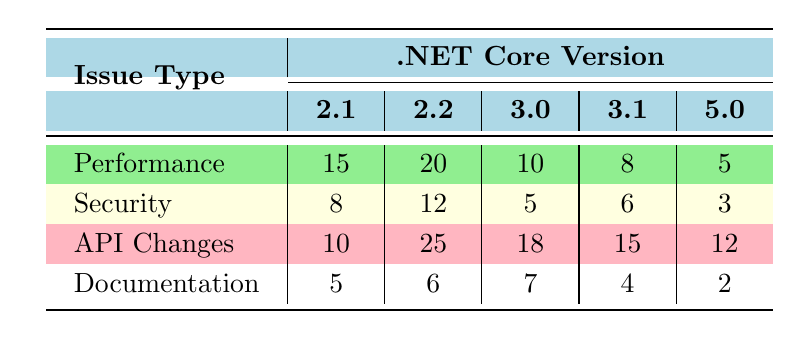What is the highest number of bug reports for the issue type 'Performance'? By examining the 'Performance' row in the table, the values are 15 for .NET Core 2.1, 20 for .NET Core 2.2, 10 for .NET Core 3.0, 8 for .NET Core 3.1, and 5 for .NET 5.0. The highest value among these is 20 for .NET Core 2.2.
Answer: 20 Which .NET version had the lowest number of bug reports for 'Security'? Looking at the 'Security' row, the values are 8 for .NET Core 2.1, 12 for .NET Core 2.2, 5 for .NET Core 3.0, 6 for .NET Core 3.1, and 3 for .NET 5.0. The lowest value is 3 for .NET 5.0.
Answer: .NET 5.0 How many total bug reports were generated for 'API Changes' across all versions? From the 'API Changes' row, we can sum the values as follows: 10 (2.1) + 25 (2.2) + 18 (3.0) + 15 (3.1) + 12 (5.0) = 10 + 25 + 18 + 15 + 12 = 80.
Answer: 80 Is the number of 'Documentation' bug reports for .NET Core 2.2 greater than the number for .NET Core 3.1? The number of 'Documentation' bug reports is 6 for .NET Core 2.2 and 4 for .NET Core 3.1. Since 6 > 4, the statement is true.
Answer: Yes What is the average number of bug reports for 'Performance' across all versions? To find the average, sum the values: 15 (2.1) + 20 (2.2) + 10 (3.0) + 8 (3.1) + 5 (5.0) = 15 + 20 + 10 + 8 + 5 = 58. There are 5 data points, so the average is 58 / 5 = 11.6.
Answer: 11.6 